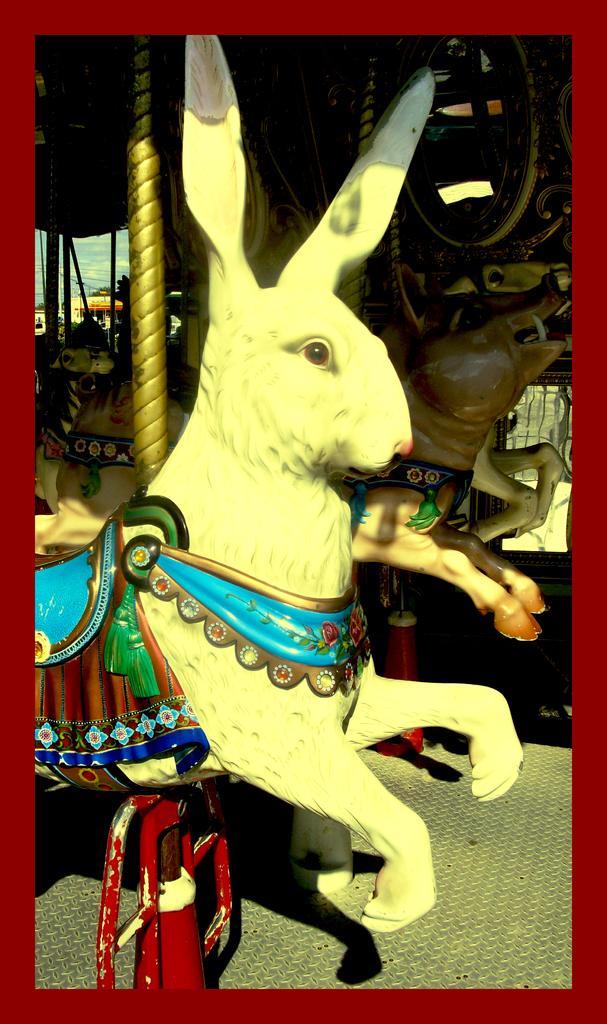In one or two sentences, can you explain what this image depicts? In this image I can see there is an object in the shape of a rabbit. At the back side there is another object in the shape of an animal. 